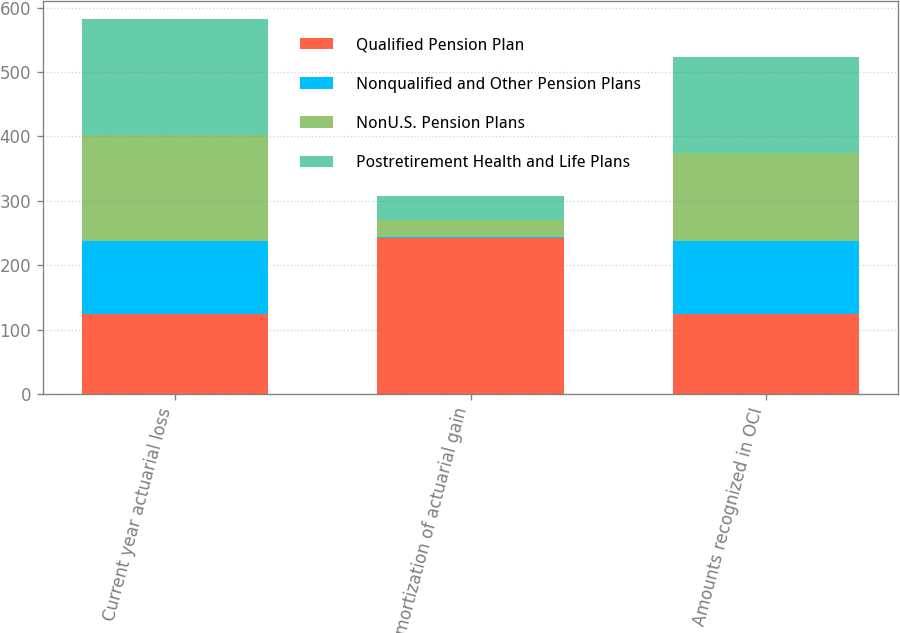<chart> <loc_0><loc_0><loc_500><loc_500><stacked_bar_chart><ecel><fcel>Current year actuarial loss<fcel>Amortization of actuarial gain<fcel>Amounts recognized in OCI<nl><fcel>Qualified Pension Plan<fcel>125<fcel>242<fcel>125<nl><fcel>Nonqualified and Other Pension Plans<fcel>113<fcel>2<fcel>113<nl><fcel>NonU.S. Pension Plans<fcel>164<fcel>27<fcel>137<nl><fcel>Postretirement Health and Life Plans<fcel>180<fcel>36<fcel>148<nl></chart> 